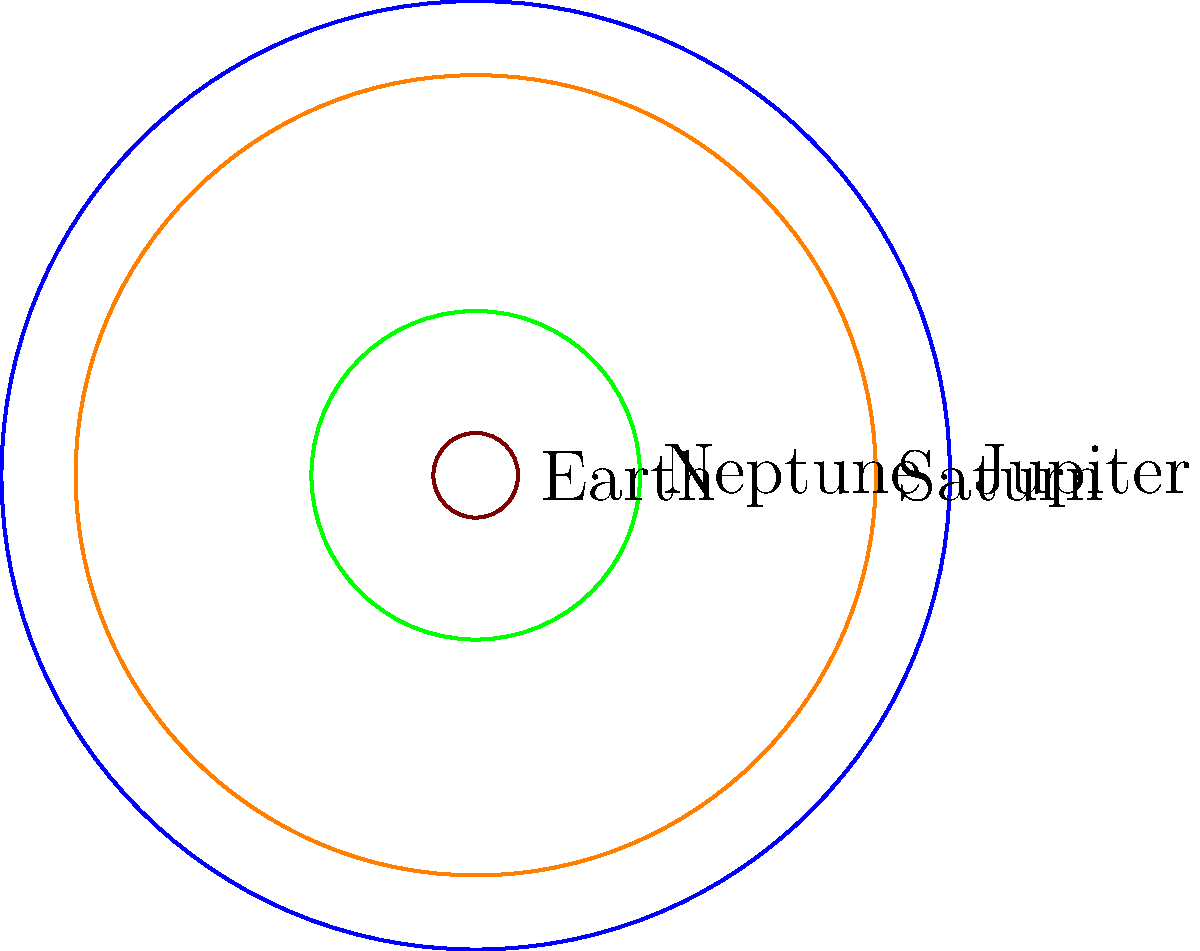In this scaled representation of planets in our solar system, which planet is represented by the green circle? To answer this question, let's analyze the diagram step-by-step:

1. We see four circles of different sizes, each representing a planet in our solar system.

2. The circles are colored blue, orange, green, and brown.

3. The diagram is scaled, meaning the sizes of the circles represent the relative sizes of the planets.

4. From largest to smallest, we have:
   - Blue (largest)
   - Orange (second largest)
   - Green (third largest)
   - Brown (smallest)

5. We know that Jupiter is the largest planet in our solar system, followed by Saturn. Earth is much smaller than these gas giants.

6. Based on this information, we can deduce:
   - Blue circle: Jupiter
   - Orange circle: Saturn
   - Brown circle: Earth (as it's the smallest)

7. The green circle, being the third largest, must represent Neptune, which is indeed larger than Earth but smaller than Jupiter and Saturn.

Therefore, the green circle represents Neptune.
Answer: Neptune 